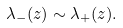<formula> <loc_0><loc_0><loc_500><loc_500>\lambda _ { - } ( z ) \sim \lambda _ { + } ( z ) .</formula> 